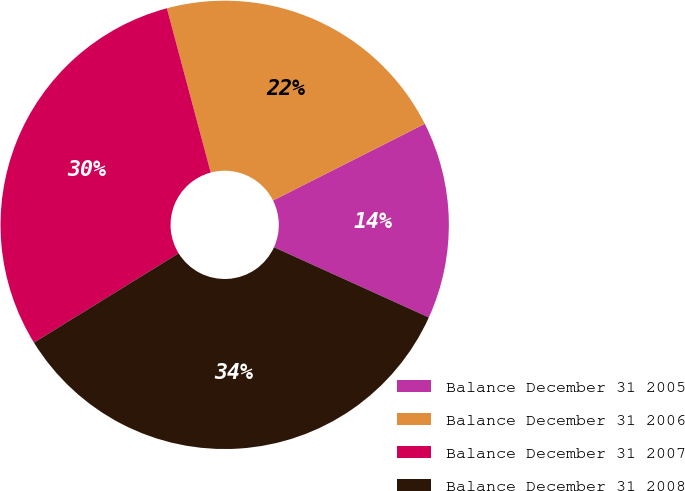Convert chart. <chart><loc_0><loc_0><loc_500><loc_500><pie_chart><fcel>Balance December 31 2005<fcel>Balance December 31 2006<fcel>Balance December 31 2007<fcel>Balance December 31 2008<nl><fcel>14.22%<fcel>21.71%<fcel>29.65%<fcel>34.42%<nl></chart> 